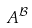Convert formula to latex. <formula><loc_0><loc_0><loc_500><loc_500>A ^ { \mathcal { B } }</formula> 